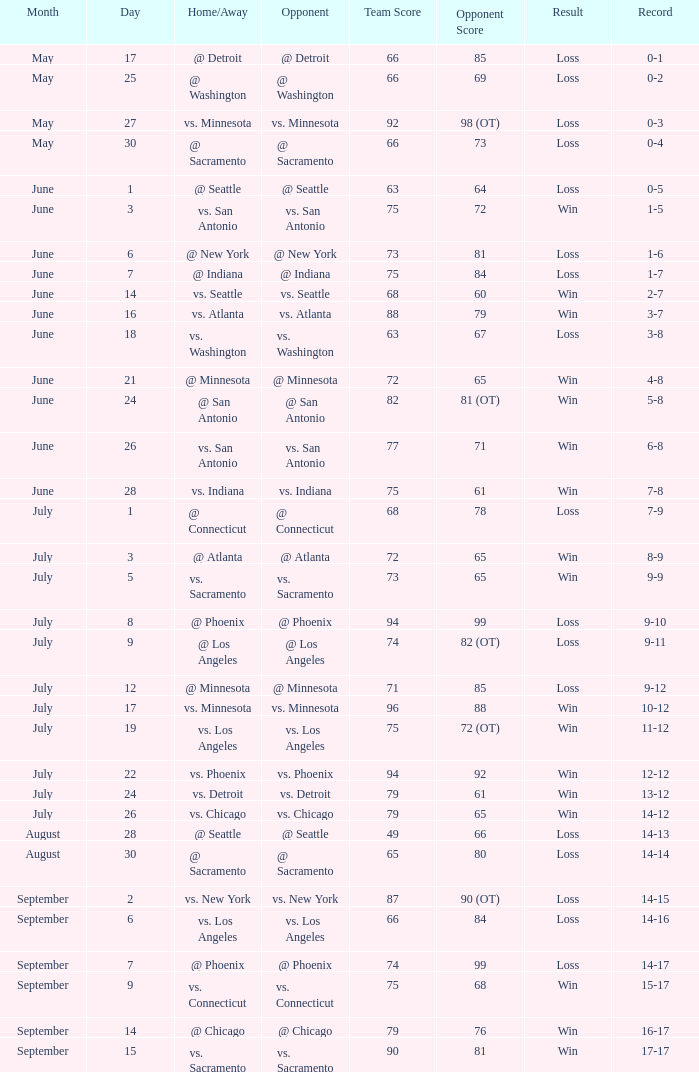What was the game's outcome on june 24th? 5-8. 